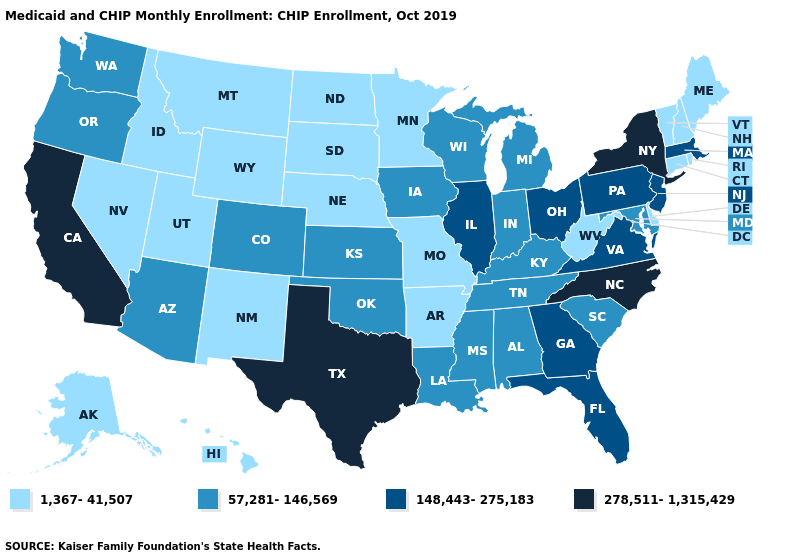What is the lowest value in the West?
Give a very brief answer. 1,367-41,507. Does Vermont have the lowest value in the USA?
Give a very brief answer. Yes. Among the states that border Maine , which have the highest value?
Be succinct. New Hampshire. Does Louisiana have the lowest value in the USA?
Answer briefly. No. Among the states that border West Virginia , does Maryland have the highest value?
Concise answer only. No. What is the value of Kentucky?
Keep it brief. 57,281-146,569. Which states have the lowest value in the MidWest?
Give a very brief answer. Minnesota, Missouri, Nebraska, North Dakota, South Dakota. Name the states that have a value in the range 278,511-1,315,429?
Be succinct. California, New York, North Carolina, Texas. Is the legend a continuous bar?
Quick response, please. No. Does Virginia have the highest value in the USA?
Give a very brief answer. No. Name the states that have a value in the range 148,443-275,183?
Quick response, please. Florida, Georgia, Illinois, Massachusetts, New Jersey, Ohio, Pennsylvania, Virginia. Among the states that border Delaware , does New Jersey have the highest value?
Be succinct. Yes. What is the value of Michigan?
Give a very brief answer. 57,281-146,569. Is the legend a continuous bar?
Keep it brief. No. Among the states that border South Dakota , does Minnesota have the highest value?
Write a very short answer. No. 